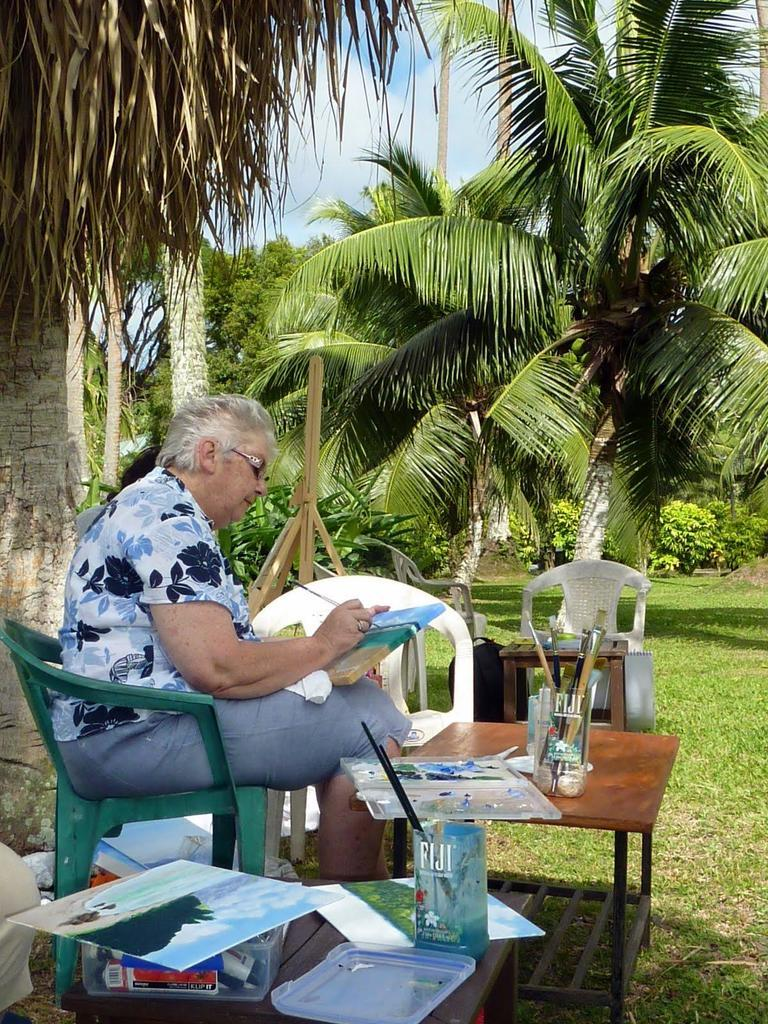What is the person in the image doing? The person is sitting on a chair in the image. How many chairs are visible in the image? There are chairs in the image. What is the main piece of furniture in the image besides the chairs? There is a table in the image. What is on the table? There are things on the table. What type of natural environment can be seen in the image? Trees and grass are visible in the image. What is the condition of the sky in the image? The sky is visible in the image, and clouds are present. What type of advertisement can be seen on the table in the image? There is no advertisement present on the table in the image. What message of peace is being conveyed by the person sitting on the chair in the image? The image does not convey any specific message of peace, as it only shows a person sitting on a chair. 